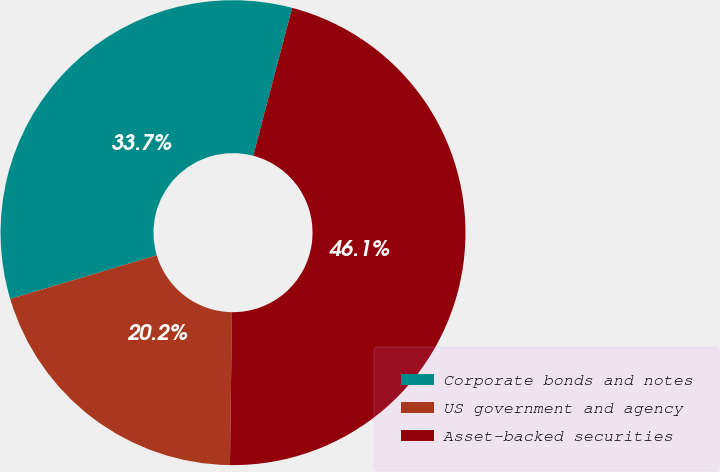Convert chart. <chart><loc_0><loc_0><loc_500><loc_500><pie_chart><fcel>Corporate bonds and notes<fcel>US government and agency<fcel>Asset-backed securities<nl><fcel>33.7%<fcel>20.19%<fcel>46.12%<nl></chart> 